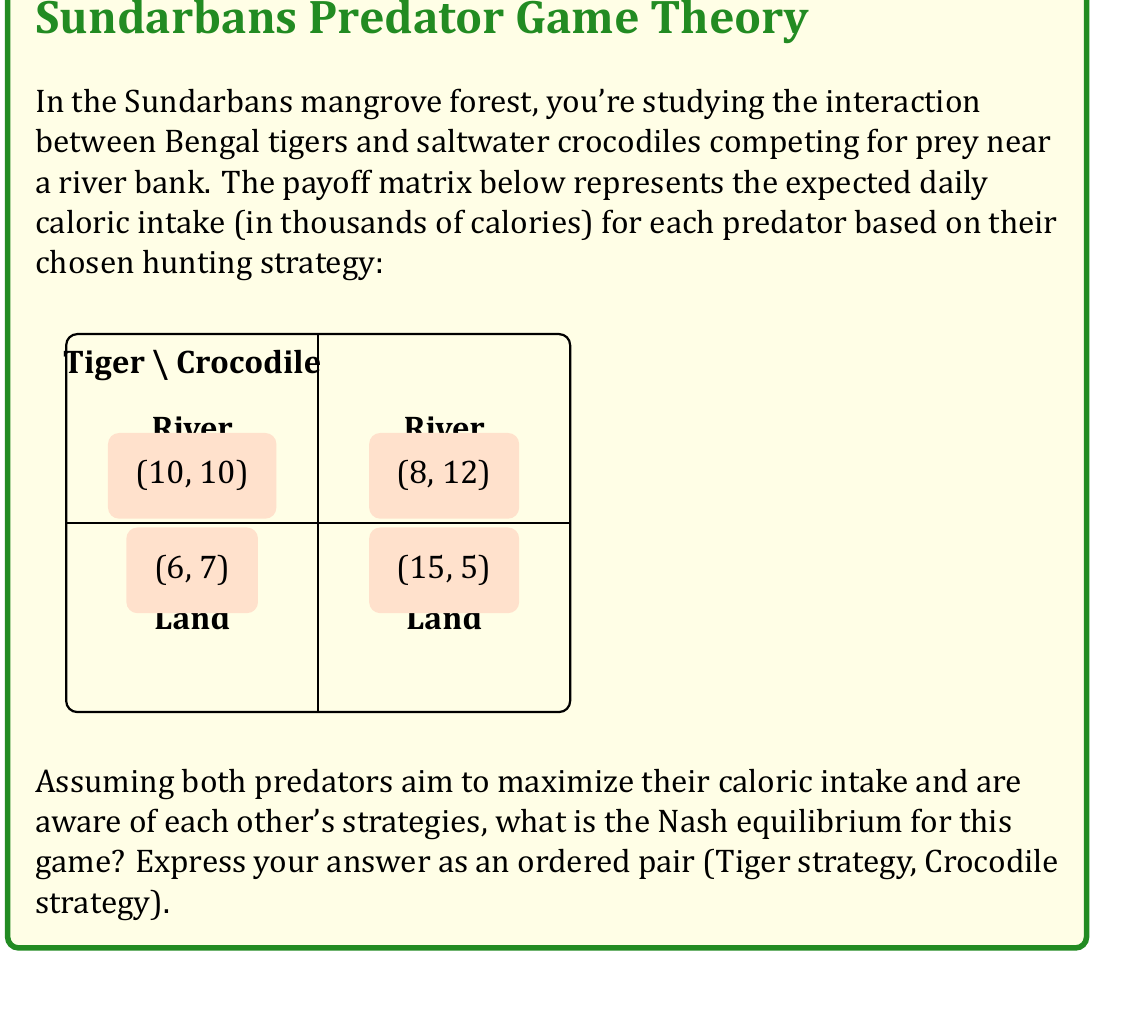Show me your answer to this math problem. To find the Nash equilibrium, we need to analyze each predator's best response to the other's strategy:

1. Tiger's perspective:
   - If Crocodile chooses River: Tiger gets 10 (River) or 6 (Land). Best response: River
   - If Crocodile chooses Land: Tiger gets 15 (River) or 6 (Land). Best response: River

2. Crocodile's perspective:
   - If Tiger chooses River: Crocodile gets 12 (River) or 5 (Land). Best response: River
   - If Tiger chooses Land: Crocodile gets 10 (River) or 7 (Land). Best response: River

3. Nash equilibrium definition: A strategy profile where no player can unilaterally improve their payoff by changing their strategy.

4. From the analysis:
   - Tiger's dominant strategy is River (always best regardless of Crocodile's choice)
   - Crocodile's dominant strategy is River (always best regardless of Tiger's choice)

5. Therefore, the Nash equilibrium is (River, River), as neither predator can improve their payoff by unilaterally changing their strategy.

This equilibrium reflects the natural tendencies of these species:
- Bengal tigers, although capable swimmers, prefer hunting near water edges.
- Saltwater crocodiles are primarily aquatic and most effective in water.

The equilibrium suggests that both predators will focus their hunting efforts near the river, which aligns with their observed behaviors in the Sundarbans ecosystem.
Answer: (River, River) 